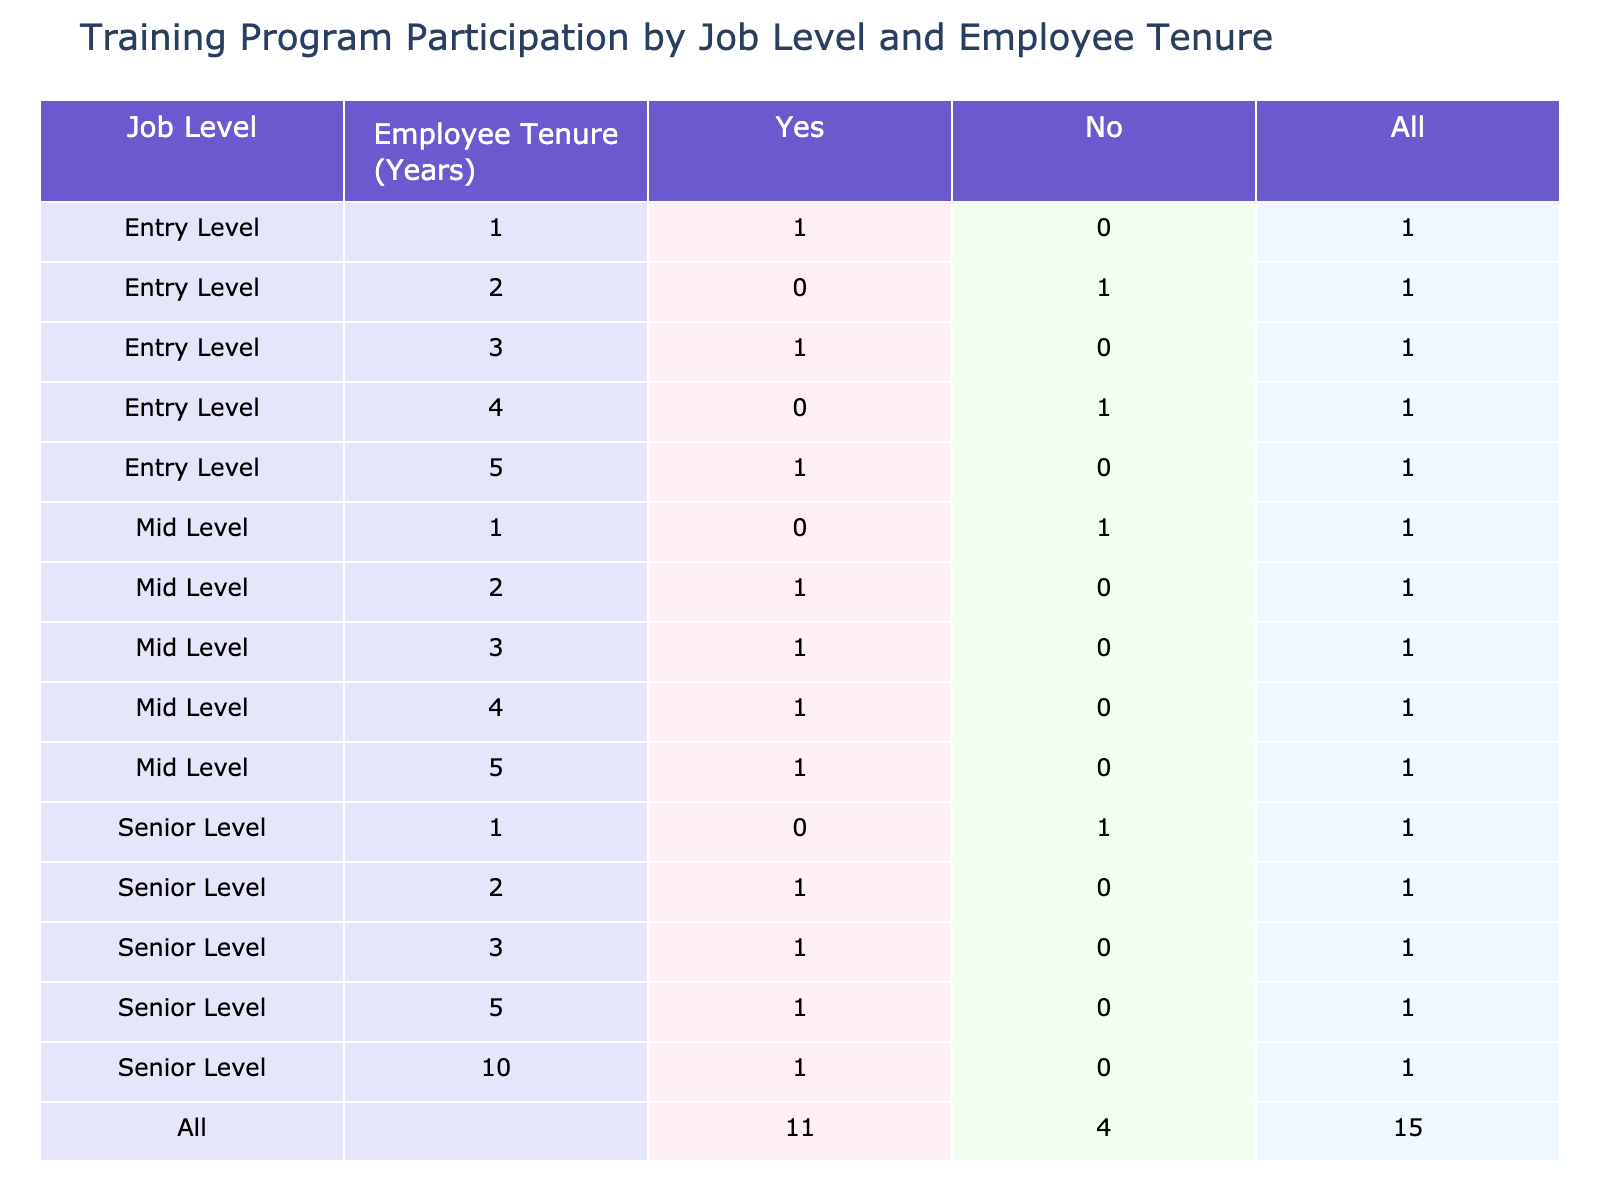What is the total number of employees who participated in the training program at the Mid Level with 3 years of tenure? From the table, we can see that the Mid Level with 3 years of tenure has 2 participants who answered "Yes" to the training program participation. The row corresponding to Mid Level and 3 years shows "Yes" with a count of 2.
Answer: 2 How many employees at Entry Level have not participated in the training program? Looking at the table, we see that for Entry Level, the counts for "No" are 2 (for 2 years) and 1 (for 4 years), totaling 3 for those who did not participate in the training program.
Answer: 3 Is there a Senior Level employee with 5 years of tenure who participated in the training program? Checking the table, there is indeed a row for Senior Level with 5 years of tenure, which shows "Yes" for the training program participation. Thus, the statement is true.
Answer: Yes What is the total training program participation for all job levels with 3 years of tenure? From the rows corresponding to 3 years of tenure (Entry Level, Mid Level, Senior Level), we see participation counts of 2 (Entry Level), 2 (Mid Level), and 2 (Senior Level). Adding these gives us 2 + 2 + 2 = 6 employees.
Answer: 6 Are there more employees at the Senior Level who participated in the training program compared to those at Entry Level? For Senior Level, the count of "Yes" is 4 (for 2, 3, and 5 years combined), while for Entry Level, the count is 2 (for 1 and 3 years combined). Since 4 is greater than 2, the answer is yes.
Answer: Yes How many employees at Mid Level have a total of 3 years or more of tenure who participated in the training? Looking at the Mid Level rows for 3 years (2 participants), 4 years (1 participant), and 5 years (1 participant), we sum these counts to get 2 + 1 + 1 = 4 employees who participated in training with 3 or more years of tenure.
Answer: 4 What is the percentage of Entry Level employees who participated in the training program? There are 5 Entry Level employees in total, and 3 participated in the training (counting the "Yes" answers). Thus, the percentage is (3/5) * 100 = 60%.
Answer: 60% Is it true that no Mid Level employee with 1 year of tenure participated in the training program? Checking this row, it shows "No" for training program participation for Mid Level with 1 year of tenure. Therefore, the stated fact is true.
Answer: True 